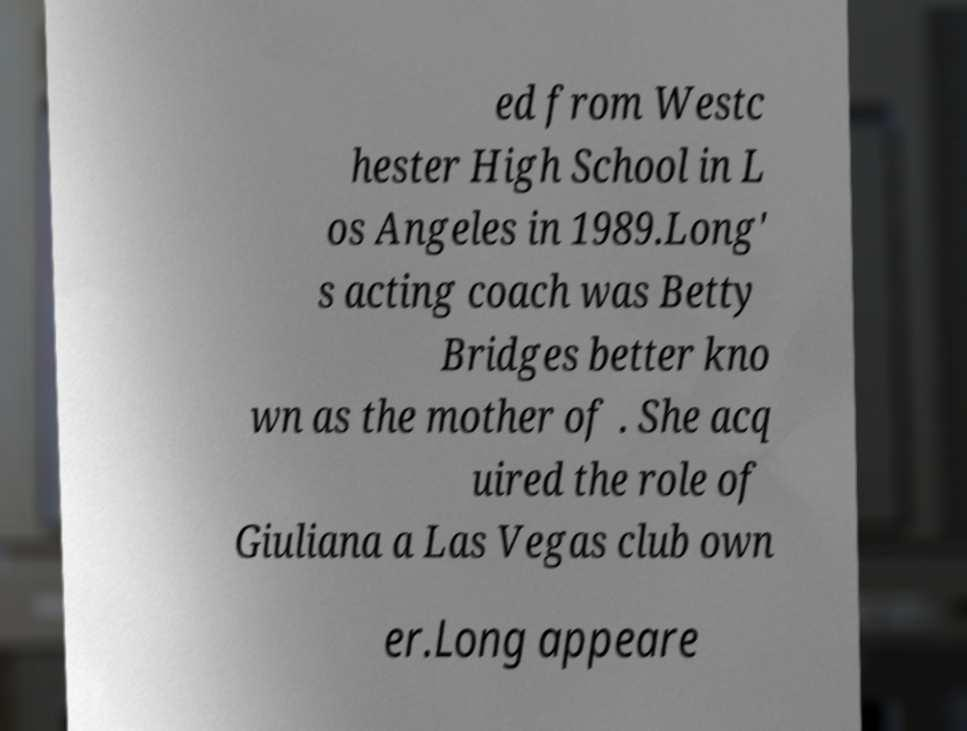What messages or text are displayed in this image? I need them in a readable, typed format. ed from Westc hester High School in L os Angeles in 1989.Long' s acting coach was Betty Bridges better kno wn as the mother of . She acq uired the role of Giuliana a Las Vegas club own er.Long appeare 